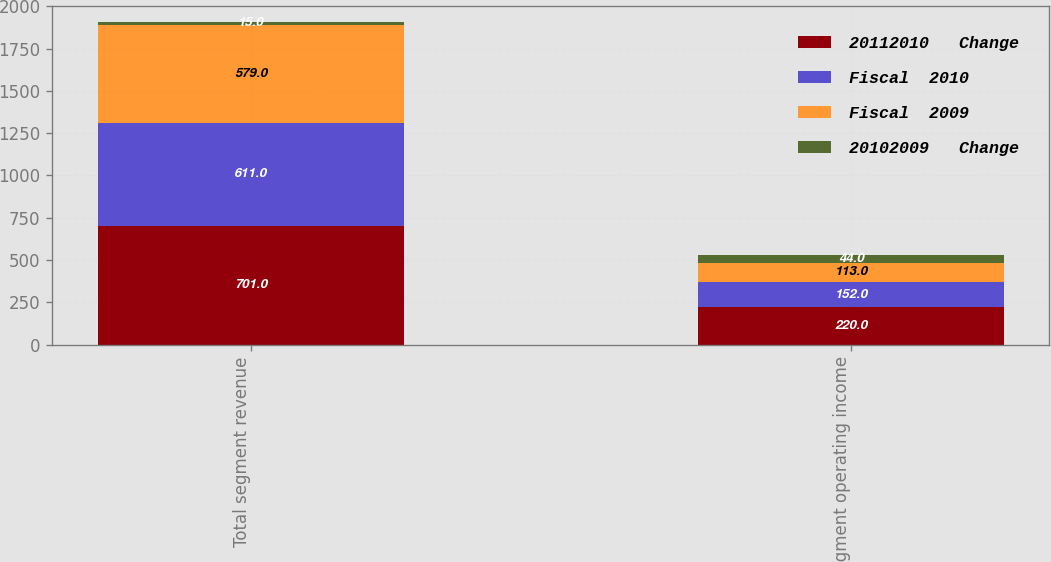<chart> <loc_0><loc_0><loc_500><loc_500><stacked_bar_chart><ecel><fcel>Total segment revenue<fcel>Segment operating income<nl><fcel>20112010   Change<fcel>701<fcel>220<nl><fcel>Fiscal  2010<fcel>611<fcel>152<nl><fcel>Fiscal  2009<fcel>579<fcel>113<nl><fcel>20102009   Change<fcel>15<fcel>44<nl></chart> 